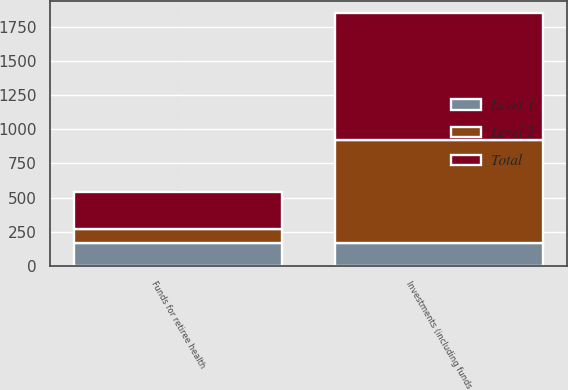Convert chart to OTSL. <chart><loc_0><loc_0><loc_500><loc_500><stacked_bar_chart><ecel><fcel>Funds for retiree health<fcel>Investments (including funds<nl><fcel>Level 1<fcel>165<fcel>165<nl><fcel>Level 2<fcel>105<fcel>759<nl><fcel>Total<fcel>270<fcel>924<nl></chart> 